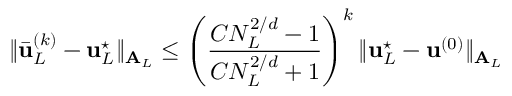<formula> <loc_0><loc_0><loc_500><loc_500>\| \bar { u } _ { L } ^ { ( k ) } - u _ { L } ^ { ^ { * } } \| _ { A _ { L } } \leq \left ( \frac { C N _ { L } ^ { 2 / d } - 1 } { C N _ { L } ^ { 2 / d } + 1 } \right ) ^ { k } \| u _ { L } ^ { ^ { * } } - u ^ { ( 0 ) } \| _ { A _ { L } }</formula> 